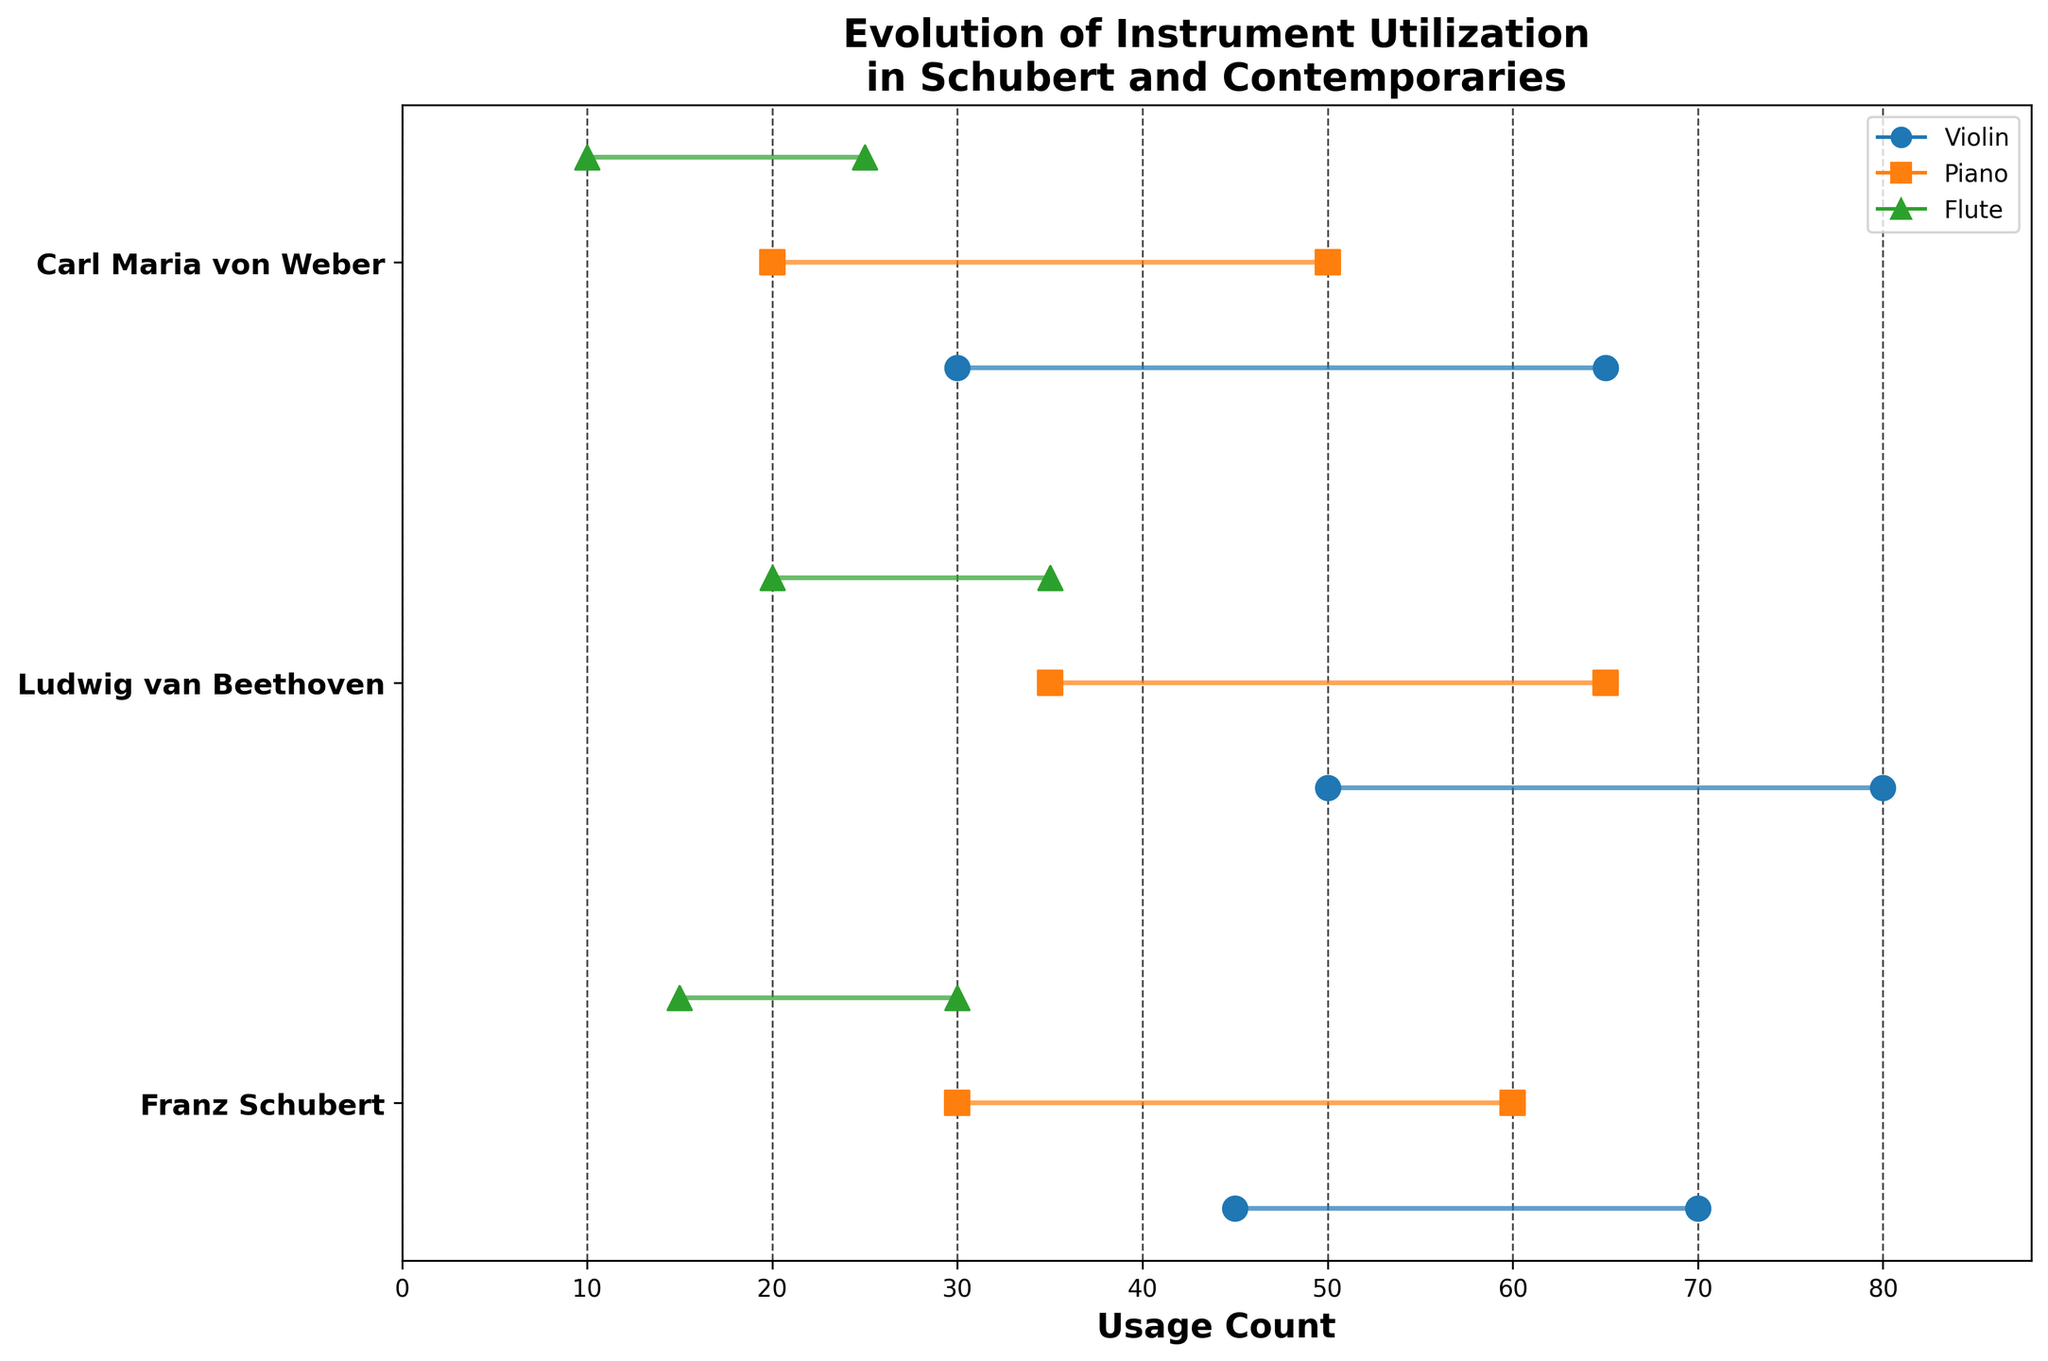What is the title of the plot? The title of the plot is located at the top of the figure and gives an overall idea of what the plot represents. By looking at the title, we can see that it says "Evolution of Instrument Utilization in Schubert and Contemporaries".
Answer: Evolution of Instrument Utilization in Schubert and Contemporaries Which instruments are plotted in the figure? The instruments can be identified from the figure's legend, where each instrument has a distinct marker and color. By referring to the legend, we can see the instruments are Violin, Piano, and Flute.
Answer: Violin, Piano, Flute How did the usage count of the Violin evolve from the Early to the Late period for Schubert? To find this, locate Schubert in the y-axis and track the position marked for "Violin" from the Early to Late period. We see that the count grows from 45 to 70. The Dumbbell between these periods confirms this as the start and end points.
Answer: From 45 to 70 Which composer had the highest usage count for Flute in the Late period? Locate the "Late" markers for "Flute" for each composer on the plot. The y-position of the markers can help trace which composer is at that position. Beethoven, with a count of 35, is the highest among all composers shown.
Answer: Beethoven What is the total usage count of the Piano for Carl Maria von Weber across all periods? To determine this, sum the usage counts for the Piano across all periods (Early, Mid, Late) for Carl Maria von Weber. According to the plot, the counts are 20 (Early), 40 (Mid), and 50 (Late). Summing these values, 20 + 40 + 50 = 110.
Answer: 110 Compare the evolution in usage count for the Flute between Beethoven and Schubert from the Early to Late period. Locate the positions of the Dumbbell markers for the Flute for both composers. For Schubert, it is from 15 (Early) to 30 (Late), and for Beethoven, it evolves from 20 to 35. Both composers show an increase, with Beethoven showing a slightly higher increase.
Answer: Beethoven's usage grew from 20 to 35, Schubert's from 15 to 30 Which period has the highest usage count of the Piano for Beethoven and what is the count? By looking at the y-positions for the Piano markers across the periods specifically for Beethoven, the highest marker in Late period shows a count of 65. The Dumbbell markers confirm Late period has the highest count.
Answer: Late period, 65 Is there any composer who used the Violin equally in both Early and Late periods? Check the starting and ending points of the Dumbbell markers for the Violin across Early and Late periods for all composers. Carl Maria von Weber shows equal usage with both periods having a count of 30.
Answer: Carl Maria von Weber Explain the usage count difference for Flute from Early to Late period for Schubert. To find the difference, subtract the Early period usage count from the Late period for Schubert's Flute usage. The plot shows 30 (Late) - 15 (Early) = 15. Therefore, the usage increased by 15.
Answer: Increased by 15 